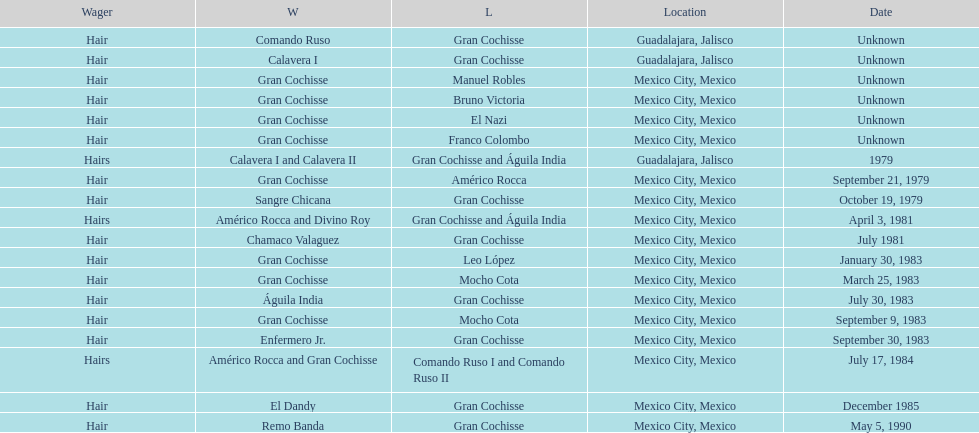What is the difference in the number of games won by sangre chicana and chamaco valaguez? 0. 